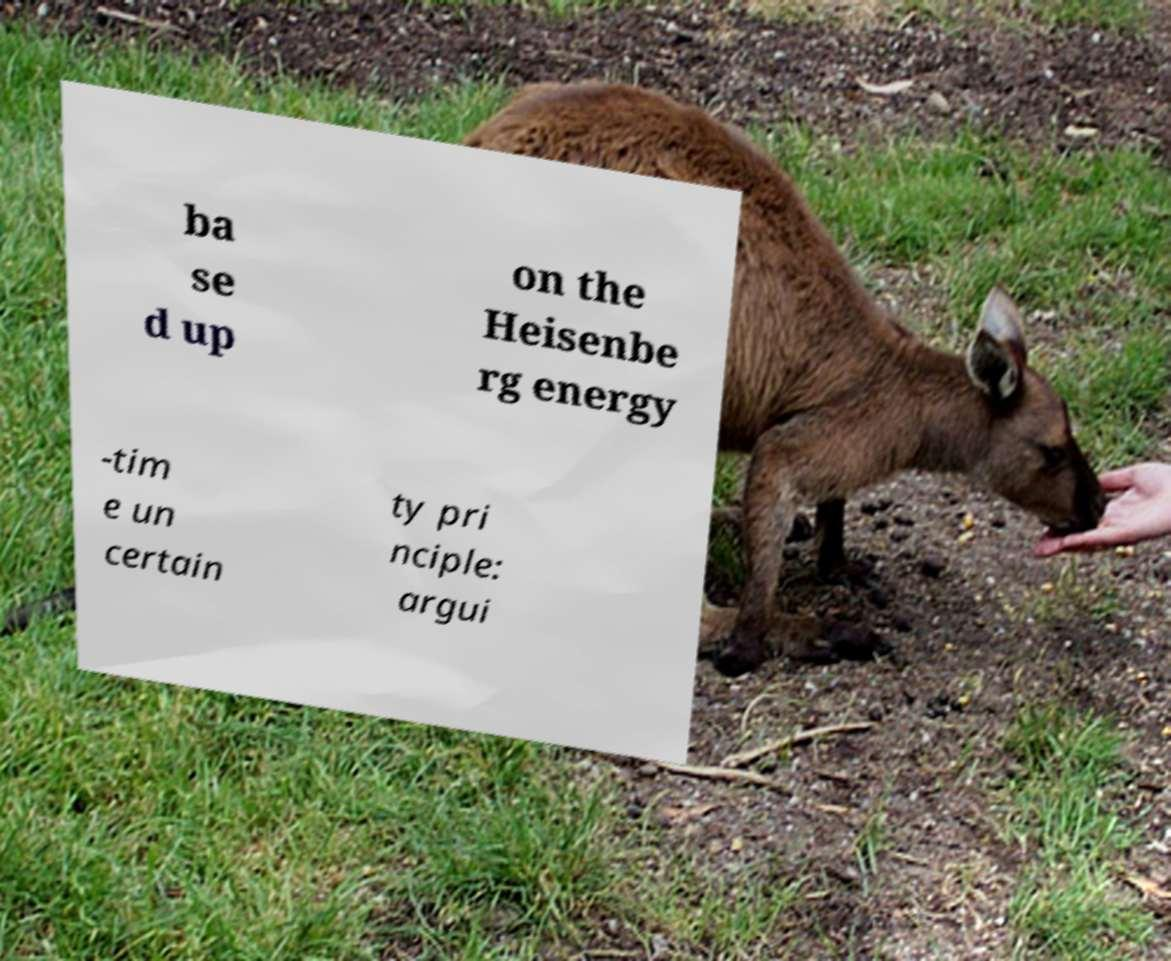For documentation purposes, I need the text within this image transcribed. Could you provide that? ba se d up on the Heisenbe rg energy -tim e un certain ty pri nciple: argui 